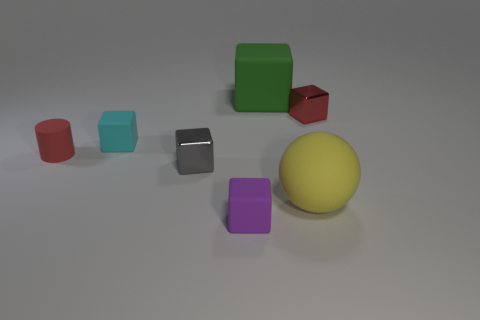Subtract all purple cubes. How many cubes are left? 4 Subtract all small blocks. How many blocks are left? 1 Subtract 0 green spheres. How many objects are left? 7 Subtract all cylinders. How many objects are left? 6 Subtract 1 spheres. How many spheres are left? 0 Subtract all red cubes. Subtract all brown cylinders. How many cubes are left? 4 Subtract all blue cylinders. How many gray blocks are left? 1 Subtract all green rubber blocks. Subtract all cyan things. How many objects are left? 5 Add 5 red matte things. How many red matte things are left? 6 Add 3 metal cubes. How many metal cubes exist? 5 